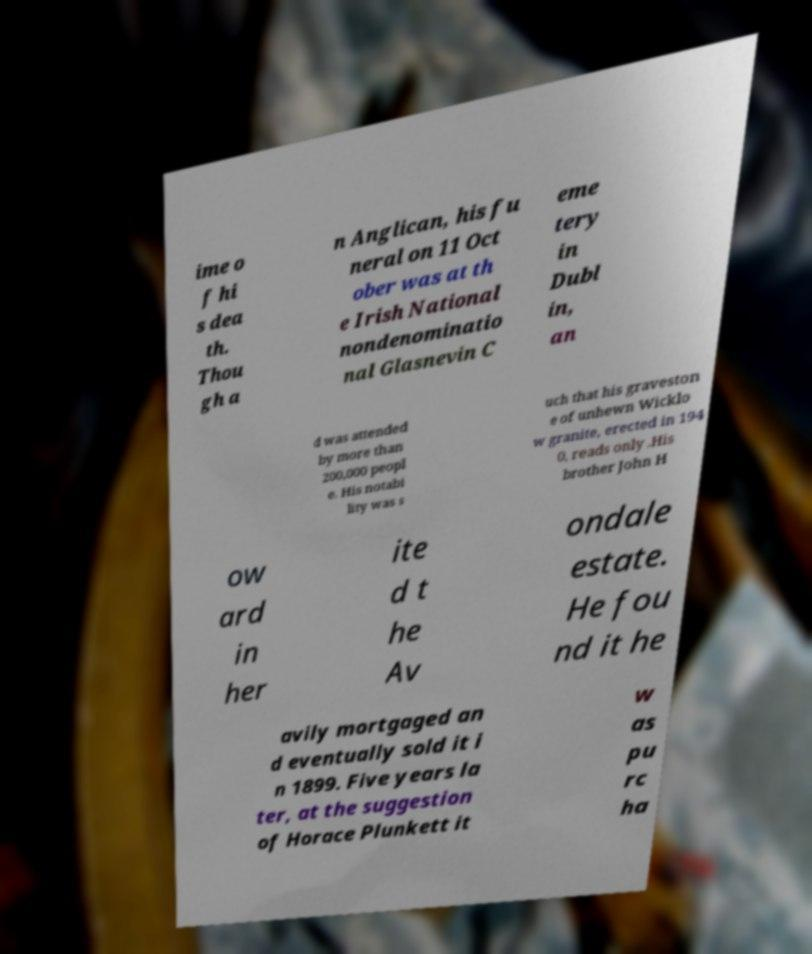Can you read and provide the text displayed in the image?This photo seems to have some interesting text. Can you extract and type it out for me? ime o f hi s dea th. Thou gh a n Anglican, his fu neral on 11 Oct ober was at th e Irish National nondenominatio nal Glasnevin C eme tery in Dubl in, an d was attended by more than 200,000 peopl e. His notabi lity was s uch that his graveston e of unhewn Wicklo w granite, erected in 194 0, reads only .His brother John H ow ard in her ite d t he Av ondale estate. He fou nd it he avily mortgaged an d eventually sold it i n 1899. Five years la ter, at the suggestion of Horace Plunkett it w as pu rc ha 